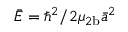Convert formula to latex. <formula><loc_0><loc_0><loc_500><loc_500>\bar { E } = \hbar { ^ } { 2 } / 2 \mu _ { 2 b } \bar { a } ^ { 2 }</formula> 